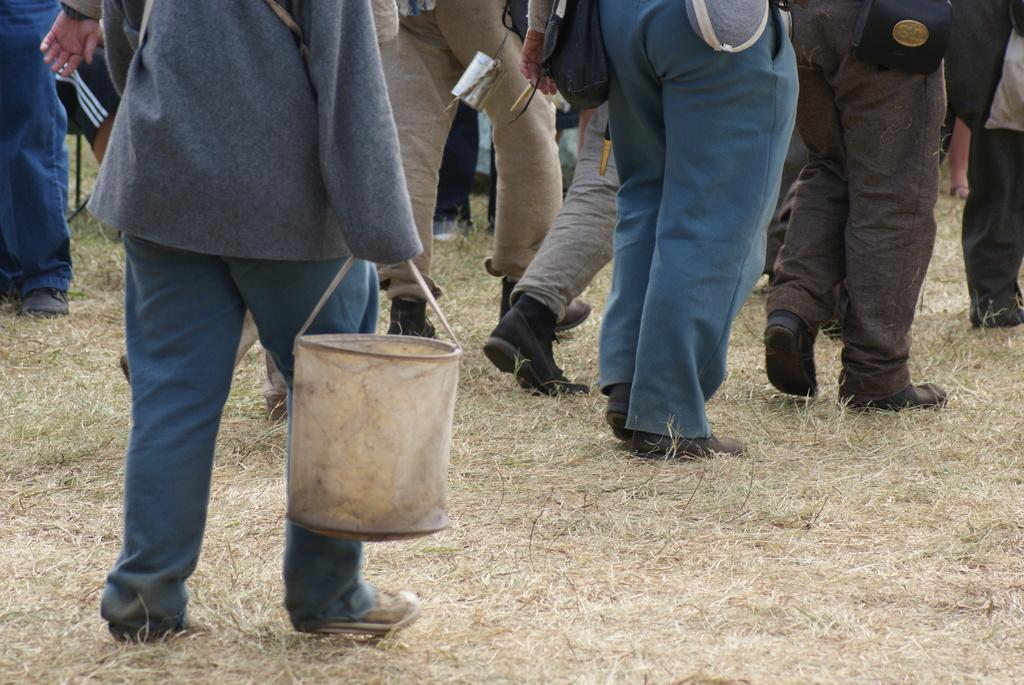What is the person in the image holding? The person in the image is holding a bag. Where is the person standing? The person is standing on the grass. Can you describe the background of the image? In the background of the image, there are many people standing on the grass. What type of destruction is the queen causing in the image? There is no queen or destruction present in the image. 